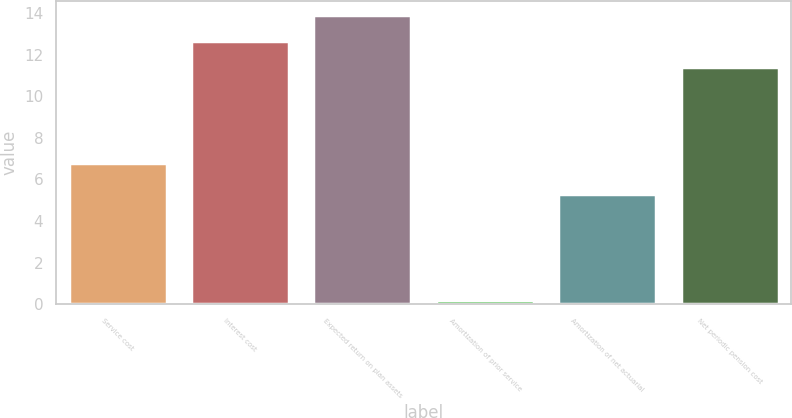Convert chart to OTSL. <chart><loc_0><loc_0><loc_500><loc_500><bar_chart><fcel>Service cost<fcel>Interest cost<fcel>Expected return on plan assets<fcel>Amortization of prior service<fcel>Amortization of net actuarial<fcel>Net periodic pension cost<nl><fcel>6.8<fcel>12.65<fcel>13.9<fcel>0.2<fcel>5.3<fcel>11.4<nl></chart> 